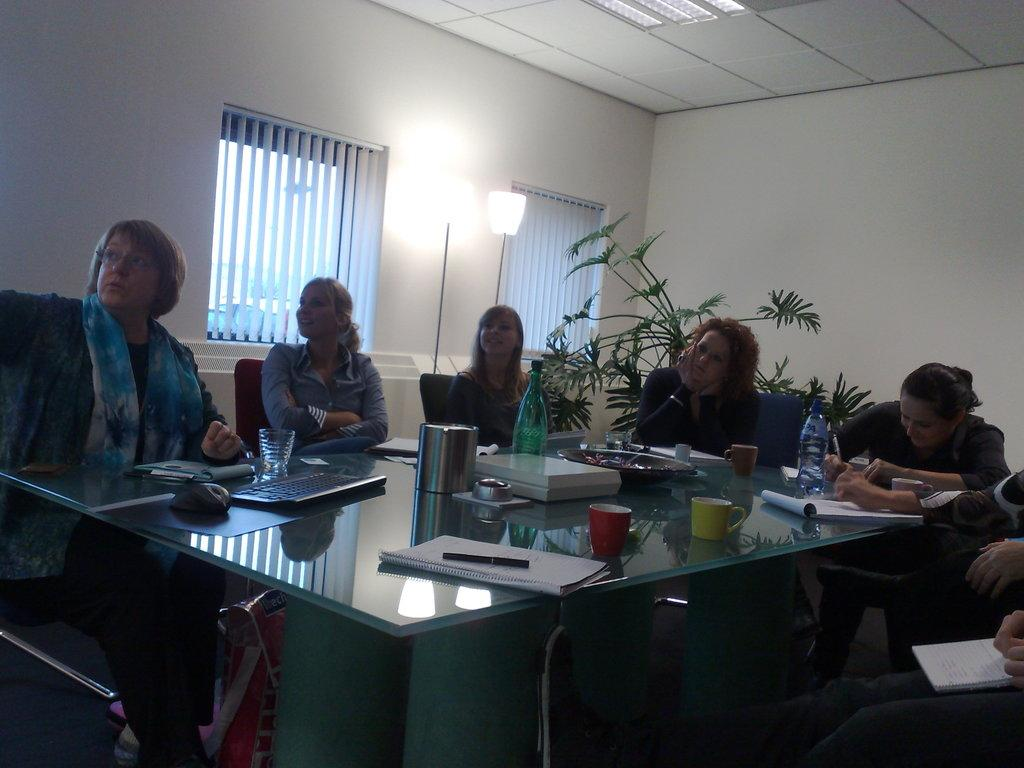What are the women doing in the image? The women are sitting in the chairs. What is in front of the women? There is a table in front of the women. What can be seen on the table? There is a water bottle, books, and papers on the table. How many pizzas are on the floor in the image? There are no pizzas present in the image, and therefore none can be found on the floor. 